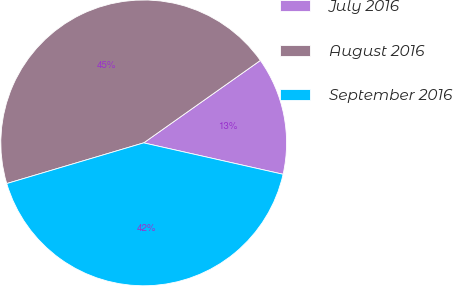Convert chart. <chart><loc_0><loc_0><loc_500><loc_500><pie_chart><fcel>July 2016<fcel>August 2016<fcel>September 2016<nl><fcel>13.32%<fcel>44.81%<fcel>41.88%<nl></chart> 